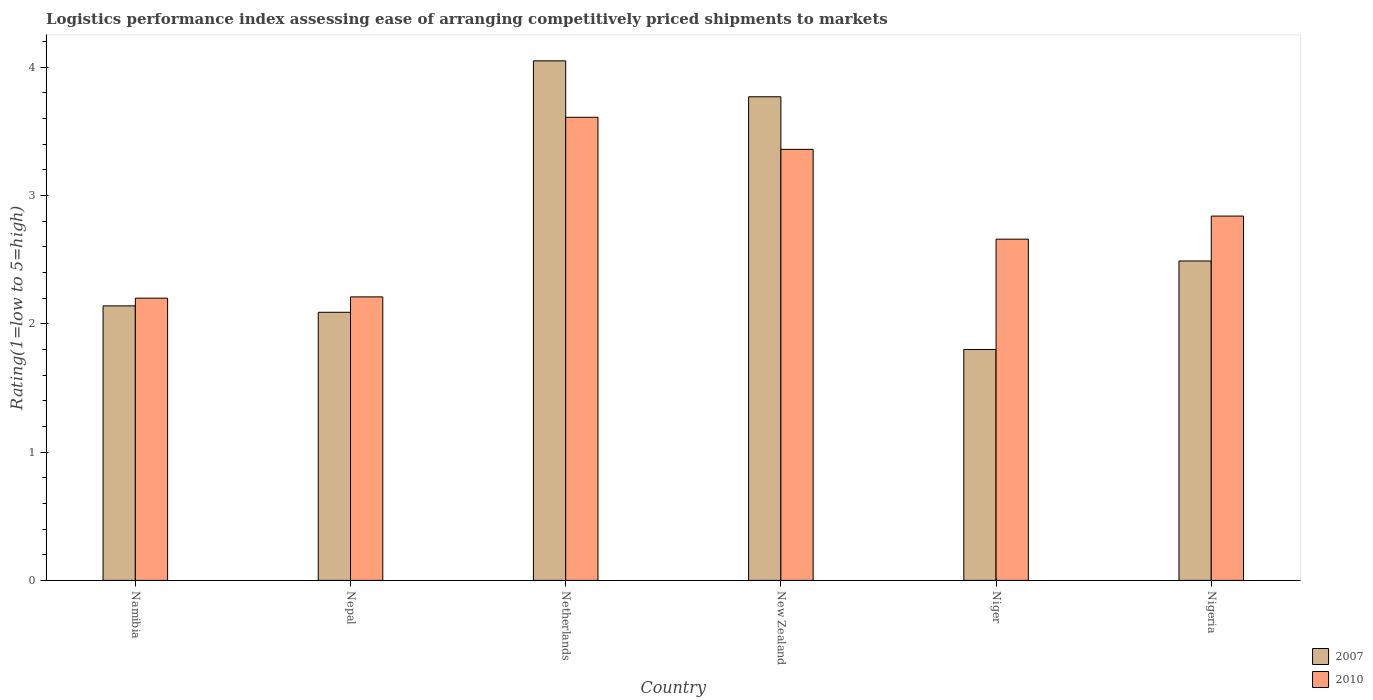How many groups of bars are there?
Your response must be concise. 6. Are the number of bars on each tick of the X-axis equal?
Offer a very short reply. Yes. How many bars are there on the 6th tick from the left?
Offer a terse response. 2. What is the label of the 1st group of bars from the left?
Provide a short and direct response. Namibia. In how many cases, is the number of bars for a given country not equal to the number of legend labels?
Make the answer very short. 0. What is the Logistic performance index in 2007 in New Zealand?
Keep it short and to the point. 3.77. Across all countries, what is the maximum Logistic performance index in 2007?
Your response must be concise. 4.05. Across all countries, what is the minimum Logistic performance index in 2007?
Give a very brief answer. 1.8. In which country was the Logistic performance index in 2007 minimum?
Your answer should be compact. Niger. What is the total Logistic performance index in 2010 in the graph?
Provide a short and direct response. 16.88. What is the difference between the Logistic performance index in 2010 in New Zealand and that in Niger?
Give a very brief answer. 0.7. What is the difference between the Logistic performance index in 2010 in Nepal and the Logistic performance index in 2007 in Namibia?
Your response must be concise. 0.07. What is the average Logistic performance index in 2007 per country?
Your answer should be very brief. 2.72. What is the difference between the Logistic performance index of/in 2007 and Logistic performance index of/in 2010 in Nepal?
Your answer should be very brief. -0.12. What is the ratio of the Logistic performance index in 2007 in Namibia to that in Niger?
Your response must be concise. 1.19. Is the difference between the Logistic performance index in 2007 in Namibia and Nigeria greater than the difference between the Logistic performance index in 2010 in Namibia and Nigeria?
Ensure brevity in your answer.  Yes. What is the difference between the highest and the second highest Logistic performance index in 2010?
Your response must be concise. 0.52. What is the difference between the highest and the lowest Logistic performance index in 2007?
Provide a short and direct response. 2.25. In how many countries, is the Logistic performance index in 2010 greater than the average Logistic performance index in 2010 taken over all countries?
Ensure brevity in your answer.  3. What does the 2nd bar from the left in New Zealand represents?
Your answer should be compact. 2010. What does the 1st bar from the right in Nigeria represents?
Your answer should be very brief. 2010. How many bars are there?
Offer a very short reply. 12. How many countries are there in the graph?
Your answer should be compact. 6. Does the graph contain any zero values?
Keep it short and to the point. No. Where does the legend appear in the graph?
Your answer should be compact. Bottom right. How are the legend labels stacked?
Provide a short and direct response. Vertical. What is the title of the graph?
Provide a short and direct response. Logistics performance index assessing ease of arranging competitively priced shipments to markets. Does "2011" appear as one of the legend labels in the graph?
Offer a terse response. No. What is the label or title of the Y-axis?
Your response must be concise. Rating(1=low to 5=high). What is the Rating(1=low to 5=high) of 2007 in Namibia?
Provide a short and direct response. 2.14. What is the Rating(1=low to 5=high) in 2010 in Namibia?
Your response must be concise. 2.2. What is the Rating(1=low to 5=high) of 2007 in Nepal?
Ensure brevity in your answer.  2.09. What is the Rating(1=low to 5=high) of 2010 in Nepal?
Offer a terse response. 2.21. What is the Rating(1=low to 5=high) in 2007 in Netherlands?
Ensure brevity in your answer.  4.05. What is the Rating(1=low to 5=high) in 2010 in Netherlands?
Provide a short and direct response. 3.61. What is the Rating(1=low to 5=high) in 2007 in New Zealand?
Make the answer very short. 3.77. What is the Rating(1=low to 5=high) in 2010 in New Zealand?
Provide a short and direct response. 3.36. What is the Rating(1=low to 5=high) of 2007 in Niger?
Offer a very short reply. 1.8. What is the Rating(1=low to 5=high) in 2010 in Niger?
Your answer should be compact. 2.66. What is the Rating(1=low to 5=high) of 2007 in Nigeria?
Offer a very short reply. 2.49. What is the Rating(1=low to 5=high) in 2010 in Nigeria?
Make the answer very short. 2.84. Across all countries, what is the maximum Rating(1=low to 5=high) in 2007?
Keep it short and to the point. 4.05. Across all countries, what is the maximum Rating(1=low to 5=high) in 2010?
Offer a terse response. 3.61. Across all countries, what is the minimum Rating(1=low to 5=high) in 2007?
Your response must be concise. 1.8. What is the total Rating(1=low to 5=high) in 2007 in the graph?
Give a very brief answer. 16.34. What is the total Rating(1=low to 5=high) in 2010 in the graph?
Provide a succinct answer. 16.88. What is the difference between the Rating(1=low to 5=high) of 2007 in Namibia and that in Nepal?
Provide a short and direct response. 0.05. What is the difference between the Rating(1=low to 5=high) of 2010 in Namibia and that in Nepal?
Ensure brevity in your answer.  -0.01. What is the difference between the Rating(1=low to 5=high) of 2007 in Namibia and that in Netherlands?
Provide a succinct answer. -1.91. What is the difference between the Rating(1=low to 5=high) of 2010 in Namibia and that in Netherlands?
Ensure brevity in your answer.  -1.41. What is the difference between the Rating(1=low to 5=high) in 2007 in Namibia and that in New Zealand?
Give a very brief answer. -1.63. What is the difference between the Rating(1=low to 5=high) of 2010 in Namibia and that in New Zealand?
Provide a succinct answer. -1.16. What is the difference between the Rating(1=low to 5=high) in 2007 in Namibia and that in Niger?
Make the answer very short. 0.34. What is the difference between the Rating(1=low to 5=high) in 2010 in Namibia and that in Niger?
Ensure brevity in your answer.  -0.46. What is the difference between the Rating(1=low to 5=high) of 2007 in Namibia and that in Nigeria?
Provide a succinct answer. -0.35. What is the difference between the Rating(1=low to 5=high) of 2010 in Namibia and that in Nigeria?
Offer a very short reply. -0.64. What is the difference between the Rating(1=low to 5=high) in 2007 in Nepal and that in Netherlands?
Offer a very short reply. -1.96. What is the difference between the Rating(1=low to 5=high) of 2007 in Nepal and that in New Zealand?
Your response must be concise. -1.68. What is the difference between the Rating(1=low to 5=high) of 2010 in Nepal and that in New Zealand?
Ensure brevity in your answer.  -1.15. What is the difference between the Rating(1=low to 5=high) of 2007 in Nepal and that in Niger?
Provide a succinct answer. 0.29. What is the difference between the Rating(1=low to 5=high) in 2010 in Nepal and that in Niger?
Provide a short and direct response. -0.45. What is the difference between the Rating(1=low to 5=high) in 2010 in Nepal and that in Nigeria?
Offer a terse response. -0.63. What is the difference between the Rating(1=low to 5=high) of 2007 in Netherlands and that in New Zealand?
Offer a very short reply. 0.28. What is the difference between the Rating(1=low to 5=high) in 2010 in Netherlands and that in New Zealand?
Ensure brevity in your answer.  0.25. What is the difference between the Rating(1=low to 5=high) of 2007 in Netherlands and that in Niger?
Provide a short and direct response. 2.25. What is the difference between the Rating(1=low to 5=high) of 2007 in Netherlands and that in Nigeria?
Keep it short and to the point. 1.56. What is the difference between the Rating(1=low to 5=high) of 2010 in Netherlands and that in Nigeria?
Give a very brief answer. 0.77. What is the difference between the Rating(1=low to 5=high) in 2007 in New Zealand and that in Niger?
Offer a very short reply. 1.97. What is the difference between the Rating(1=low to 5=high) in 2007 in New Zealand and that in Nigeria?
Make the answer very short. 1.28. What is the difference between the Rating(1=low to 5=high) in 2010 in New Zealand and that in Nigeria?
Offer a very short reply. 0.52. What is the difference between the Rating(1=low to 5=high) of 2007 in Niger and that in Nigeria?
Make the answer very short. -0.69. What is the difference between the Rating(1=low to 5=high) in 2010 in Niger and that in Nigeria?
Offer a very short reply. -0.18. What is the difference between the Rating(1=low to 5=high) of 2007 in Namibia and the Rating(1=low to 5=high) of 2010 in Nepal?
Provide a succinct answer. -0.07. What is the difference between the Rating(1=low to 5=high) in 2007 in Namibia and the Rating(1=low to 5=high) in 2010 in Netherlands?
Your response must be concise. -1.47. What is the difference between the Rating(1=low to 5=high) of 2007 in Namibia and the Rating(1=low to 5=high) of 2010 in New Zealand?
Your answer should be very brief. -1.22. What is the difference between the Rating(1=low to 5=high) in 2007 in Namibia and the Rating(1=low to 5=high) in 2010 in Niger?
Offer a very short reply. -0.52. What is the difference between the Rating(1=low to 5=high) in 2007 in Namibia and the Rating(1=low to 5=high) in 2010 in Nigeria?
Your response must be concise. -0.7. What is the difference between the Rating(1=low to 5=high) of 2007 in Nepal and the Rating(1=low to 5=high) of 2010 in Netherlands?
Your answer should be compact. -1.52. What is the difference between the Rating(1=low to 5=high) in 2007 in Nepal and the Rating(1=low to 5=high) in 2010 in New Zealand?
Keep it short and to the point. -1.27. What is the difference between the Rating(1=low to 5=high) of 2007 in Nepal and the Rating(1=low to 5=high) of 2010 in Niger?
Offer a terse response. -0.57. What is the difference between the Rating(1=low to 5=high) in 2007 in Nepal and the Rating(1=low to 5=high) in 2010 in Nigeria?
Provide a succinct answer. -0.75. What is the difference between the Rating(1=low to 5=high) of 2007 in Netherlands and the Rating(1=low to 5=high) of 2010 in New Zealand?
Make the answer very short. 0.69. What is the difference between the Rating(1=low to 5=high) of 2007 in Netherlands and the Rating(1=low to 5=high) of 2010 in Niger?
Your answer should be compact. 1.39. What is the difference between the Rating(1=low to 5=high) of 2007 in Netherlands and the Rating(1=low to 5=high) of 2010 in Nigeria?
Your answer should be compact. 1.21. What is the difference between the Rating(1=low to 5=high) in 2007 in New Zealand and the Rating(1=low to 5=high) in 2010 in Niger?
Your answer should be compact. 1.11. What is the difference between the Rating(1=low to 5=high) in 2007 in New Zealand and the Rating(1=low to 5=high) in 2010 in Nigeria?
Give a very brief answer. 0.93. What is the difference between the Rating(1=low to 5=high) in 2007 in Niger and the Rating(1=low to 5=high) in 2010 in Nigeria?
Provide a succinct answer. -1.04. What is the average Rating(1=low to 5=high) in 2007 per country?
Provide a short and direct response. 2.72. What is the average Rating(1=low to 5=high) in 2010 per country?
Provide a short and direct response. 2.81. What is the difference between the Rating(1=low to 5=high) in 2007 and Rating(1=low to 5=high) in 2010 in Namibia?
Provide a short and direct response. -0.06. What is the difference between the Rating(1=low to 5=high) of 2007 and Rating(1=low to 5=high) of 2010 in Nepal?
Offer a terse response. -0.12. What is the difference between the Rating(1=low to 5=high) of 2007 and Rating(1=low to 5=high) of 2010 in Netherlands?
Ensure brevity in your answer.  0.44. What is the difference between the Rating(1=low to 5=high) of 2007 and Rating(1=low to 5=high) of 2010 in New Zealand?
Your answer should be very brief. 0.41. What is the difference between the Rating(1=low to 5=high) of 2007 and Rating(1=low to 5=high) of 2010 in Niger?
Your response must be concise. -0.86. What is the difference between the Rating(1=low to 5=high) of 2007 and Rating(1=low to 5=high) of 2010 in Nigeria?
Your response must be concise. -0.35. What is the ratio of the Rating(1=low to 5=high) in 2007 in Namibia to that in Nepal?
Keep it short and to the point. 1.02. What is the ratio of the Rating(1=low to 5=high) in 2007 in Namibia to that in Netherlands?
Provide a succinct answer. 0.53. What is the ratio of the Rating(1=low to 5=high) in 2010 in Namibia to that in Netherlands?
Offer a very short reply. 0.61. What is the ratio of the Rating(1=low to 5=high) in 2007 in Namibia to that in New Zealand?
Your answer should be very brief. 0.57. What is the ratio of the Rating(1=low to 5=high) in 2010 in Namibia to that in New Zealand?
Provide a short and direct response. 0.65. What is the ratio of the Rating(1=low to 5=high) of 2007 in Namibia to that in Niger?
Your response must be concise. 1.19. What is the ratio of the Rating(1=low to 5=high) of 2010 in Namibia to that in Niger?
Your answer should be compact. 0.83. What is the ratio of the Rating(1=low to 5=high) of 2007 in Namibia to that in Nigeria?
Provide a short and direct response. 0.86. What is the ratio of the Rating(1=low to 5=high) in 2010 in Namibia to that in Nigeria?
Make the answer very short. 0.77. What is the ratio of the Rating(1=low to 5=high) of 2007 in Nepal to that in Netherlands?
Give a very brief answer. 0.52. What is the ratio of the Rating(1=low to 5=high) of 2010 in Nepal to that in Netherlands?
Your answer should be very brief. 0.61. What is the ratio of the Rating(1=low to 5=high) of 2007 in Nepal to that in New Zealand?
Provide a short and direct response. 0.55. What is the ratio of the Rating(1=low to 5=high) in 2010 in Nepal to that in New Zealand?
Offer a terse response. 0.66. What is the ratio of the Rating(1=low to 5=high) in 2007 in Nepal to that in Niger?
Your answer should be compact. 1.16. What is the ratio of the Rating(1=low to 5=high) of 2010 in Nepal to that in Niger?
Offer a very short reply. 0.83. What is the ratio of the Rating(1=low to 5=high) in 2007 in Nepal to that in Nigeria?
Your answer should be compact. 0.84. What is the ratio of the Rating(1=low to 5=high) in 2010 in Nepal to that in Nigeria?
Your answer should be very brief. 0.78. What is the ratio of the Rating(1=low to 5=high) of 2007 in Netherlands to that in New Zealand?
Your answer should be compact. 1.07. What is the ratio of the Rating(1=low to 5=high) in 2010 in Netherlands to that in New Zealand?
Ensure brevity in your answer.  1.07. What is the ratio of the Rating(1=low to 5=high) of 2007 in Netherlands to that in Niger?
Your answer should be very brief. 2.25. What is the ratio of the Rating(1=low to 5=high) in 2010 in Netherlands to that in Niger?
Your answer should be compact. 1.36. What is the ratio of the Rating(1=low to 5=high) in 2007 in Netherlands to that in Nigeria?
Provide a succinct answer. 1.63. What is the ratio of the Rating(1=low to 5=high) in 2010 in Netherlands to that in Nigeria?
Give a very brief answer. 1.27. What is the ratio of the Rating(1=low to 5=high) of 2007 in New Zealand to that in Niger?
Your answer should be compact. 2.09. What is the ratio of the Rating(1=low to 5=high) of 2010 in New Zealand to that in Niger?
Your answer should be very brief. 1.26. What is the ratio of the Rating(1=low to 5=high) of 2007 in New Zealand to that in Nigeria?
Keep it short and to the point. 1.51. What is the ratio of the Rating(1=low to 5=high) in 2010 in New Zealand to that in Nigeria?
Offer a very short reply. 1.18. What is the ratio of the Rating(1=low to 5=high) in 2007 in Niger to that in Nigeria?
Your answer should be very brief. 0.72. What is the ratio of the Rating(1=low to 5=high) of 2010 in Niger to that in Nigeria?
Offer a very short reply. 0.94. What is the difference between the highest and the second highest Rating(1=low to 5=high) in 2007?
Give a very brief answer. 0.28. What is the difference between the highest and the lowest Rating(1=low to 5=high) of 2007?
Provide a short and direct response. 2.25. What is the difference between the highest and the lowest Rating(1=low to 5=high) of 2010?
Provide a short and direct response. 1.41. 